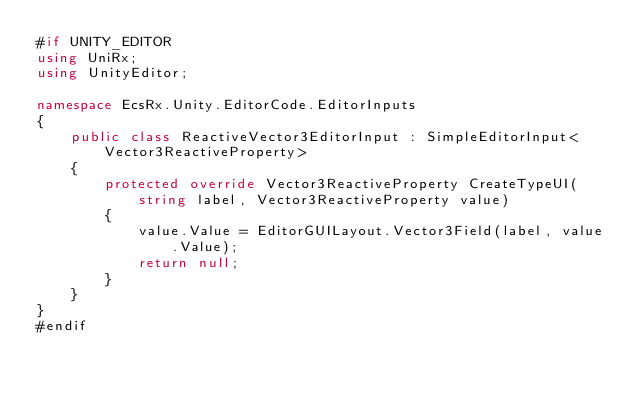Convert code to text. <code><loc_0><loc_0><loc_500><loc_500><_C#_>#if UNITY_EDITOR
using UniRx;
using UnityEditor;

namespace EcsRx.Unity.EditorCode.EditorInputs
{
    public class ReactiveVector3EditorInput : SimpleEditorInput<Vector3ReactiveProperty>
    {
        protected override Vector3ReactiveProperty CreateTypeUI(string label, Vector3ReactiveProperty value)
        {
            value.Value = EditorGUILayout.Vector3Field(label, value.Value);
            return null;
        }
    }
}
#endif</code> 